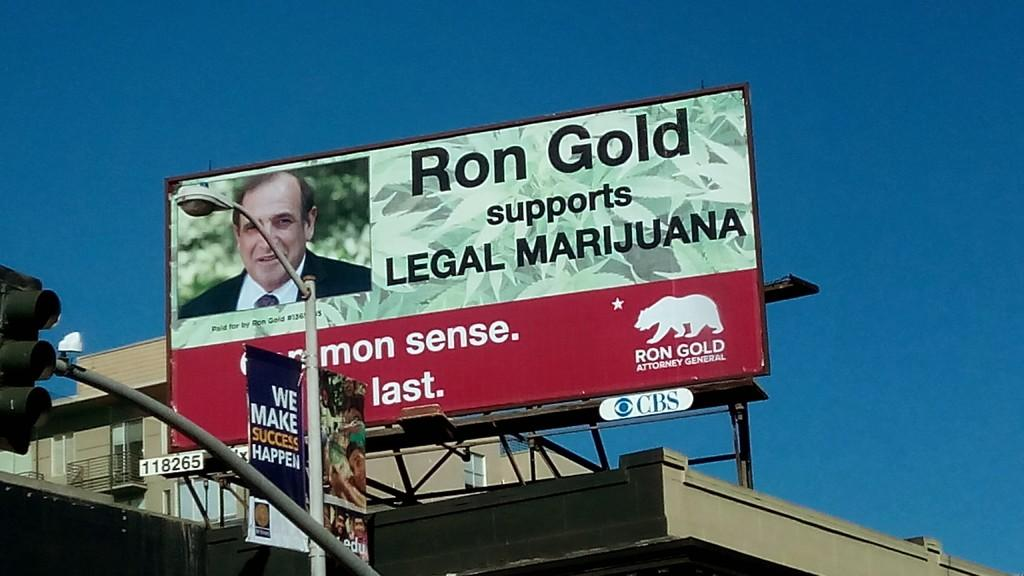Provide a one-sentence caption for the provided image. A candidate named Ron Gold wants to legalize marijuana. 